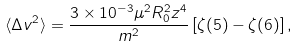Convert formula to latex. <formula><loc_0><loc_0><loc_500><loc_500>\langle \Delta v ^ { 2 } \rangle = \frac { 3 \times 1 0 ^ { - 3 } \mu ^ { 2 } R _ { 0 } ^ { 2 } z ^ { 4 } } { m ^ { 2 } } \left [ \zeta ( 5 ) - \zeta ( 6 ) \right ] ,</formula> 